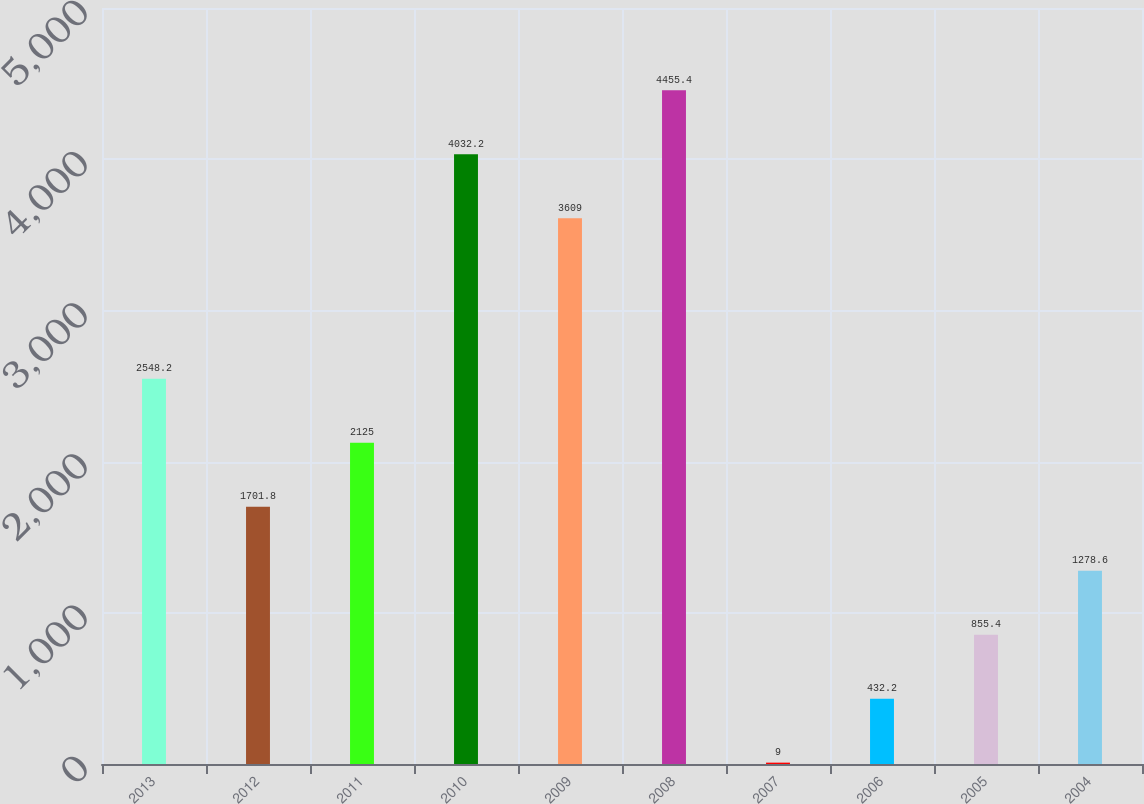Convert chart. <chart><loc_0><loc_0><loc_500><loc_500><bar_chart><fcel>2013<fcel>2012<fcel>2011<fcel>2010<fcel>2009<fcel>2008<fcel>2007<fcel>2006<fcel>2005<fcel>2004<nl><fcel>2548.2<fcel>1701.8<fcel>2125<fcel>4032.2<fcel>3609<fcel>4455.4<fcel>9<fcel>432.2<fcel>855.4<fcel>1278.6<nl></chart> 